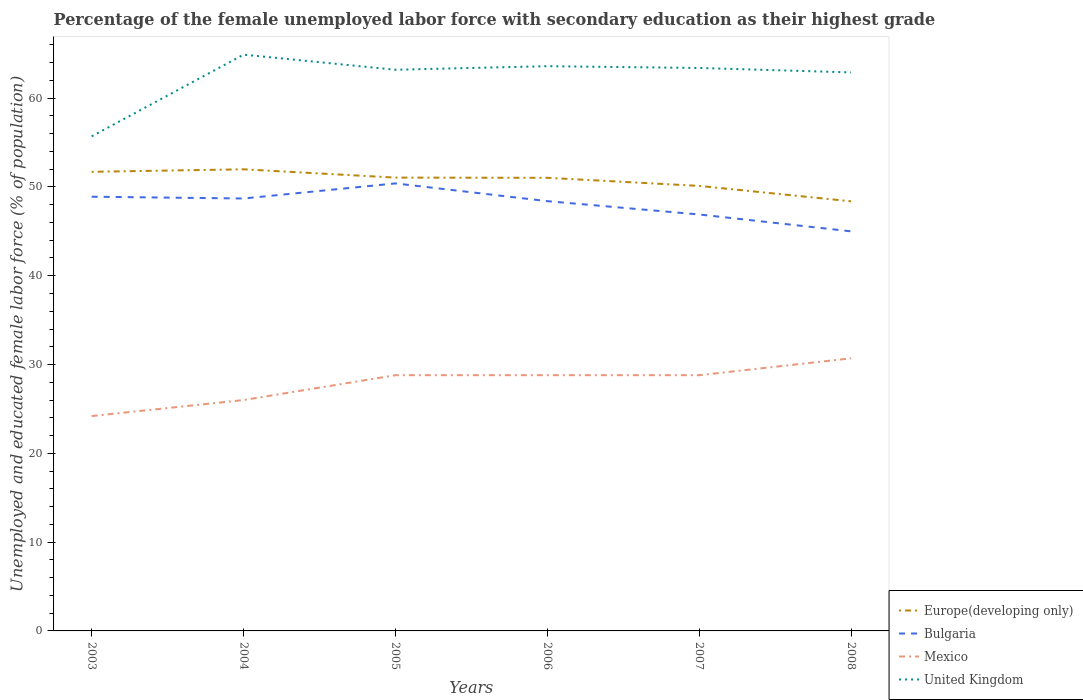How many different coloured lines are there?
Offer a terse response. 4. Is the number of lines equal to the number of legend labels?
Your response must be concise. Yes. What is the total percentage of the unemployed female labor force with secondary education in United Kingdom in the graph?
Your response must be concise. -7.9. Is the percentage of the unemployed female labor force with secondary education in United Kingdom strictly greater than the percentage of the unemployed female labor force with secondary education in Europe(developing only) over the years?
Provide a succinct answer. No. How many years are there in the graph?
Make the answer very short. 6. Are the values on the major ticks of Y-axis written in scientific E-notation?
Provide a succinct answer. No. Does the graph contain grids?
Give a very brief answer. No. Where does the legend appear in the graph?
Offer a terse response. Bottom right. How are the legend labels stacked?
Your answer should be compact. Vertical. What is the title of the graph?
Offer a very short reply. Percentage of the female unemployed labor force with secondary education as their highest grade. Does "Aruba" appear as one of the legend labels in the graph?
Offer a very short reply. No. What is the label or title of the X-axis?
Provide a short and direct response. Years. What is the label or title of the Y-axis?
Your response must be concise. Unemployed and educated female labor force (% of population). What is the Unemployed and educated female labor force (% of population) of Europe(developing only) in 2003?
Make the answer very short. 51.71. What is the Unemployed and educated female labor force (% of population) in Bulgaria in 2003?
Ensure brevity in your answer.  48.9. What is the Unemployed and educated female labor force (% of population) in Mexico in 2003?
Your response must be concise. 24.2. What is the Unemployed and educated female labor force (% of population) of United Kingdom in 2003?
Offer a terse response. 55.7. What is the Unemployed and educated female labor force (% of population) of Europe(developing only) in 2004?
Your answer should be very brief. 51.99. What is the Unemployed and educated female labor force (% of population) of Bulgaria in 2004?
Your response must be concise. 48.7. What is the Unemployed and educated female labor force (% of population) in Mexico in 2004?
Offer a very short reply. 26. What is the Unemployed and educated female labor force (% of population) in United Kingdom in 2004?
Your answer should be very brief. 64.9. What is the Unemployed and educated female labor force (% of population) in Europe(developing only) in 2005?
Provide a succinct answer. 51.05. What is the Unemployed and educated female labor force (% of population) in Bulgaria in 2005?
Give a very brief answer. 50.4. What is the Unemployed and educated female labor force (% of population) in Mexico in 2005?
Ensure brevity in your answer.  28.8. What is the Unemployed and educated female labor force (% of population) in United Kingdom in 2005?
Offer a very short reply. 63.2. What is the Unemployed and educated female labor force (% of population) of Europe(developing only) in 2006?
Offer a terse response. 51.03. What is the Unemployed and educated female labor force (% of population) in Bulgaria in 2006?
Offer a terse response. 48.4. What is the Unemployed and educated female labor force (% of population) in Mexico in 2006?
Offer a terse response. 28.8. What is the Unemployed and educated female labor force (% of population) of United Kingdom in 2006?
Ensure brevity in your answer.  63.6. What is the Unemployed and educated female labor force (% of population) in Europe(developing only) in 2007?
Your response must be concise. 50.12. What is the Unemployed and educated female labor force (% of population) of Bulgaria in 2007?
Your answer should be compact. 46.9. What is the Unemployed and educated female labor force (% of population) in Mexico in 2007?
Your answer should be very brief. 28.8. What is the Unemployed and educated female labor force (% of population) in United Kingdom in 2007?
Make the answer very short. 63.4. What is the Unemployed and educated female labor force (% of population) of Europe(developing only) in 2008?
Provide a short and direct response. 48.38. What is the Unemployed and educated female labor force (% of population) of Bulgaria in 2008?
Offer a very short reply. 45. What is the Unemployed and educated female labor force (% of population) of Mexico in 2008?
Provide a short and direct response. 30.7. What is the Unemployed and educated female labor force (% of population) in United Kingdom in 2008?
Make the answer very short. 62.9. Across all years, what is the maximum Unemployed and educated female labor force (% of population) in Europe(developing only)?
Provide a short and direct response. 51.99. Across all years, what is the maximum Unemployed and educated female labor force (% of population) in Bulgaria?
Offer a very short reply. 50.4. Across all years, what is the maximum Unemployed and educated female labor force (% of population) in Mexico?
Make the answer very short. 30.7. Across all years, what is the maximum Unemployed and educated female labor force (% of population) of United Kingdom?
Give a very brief answer. 64.9. Across all years, what is the minimum Unemployed and educated female labor force (% of population) of Europe(developing only)?
Ensure brevity in your answer.  48.38. Across all years, what is the minimum Unemployed and educated female labor force (% of population) in Bulgaria?
Offer a terse response. 45. Across all years, what is the minimum Unemployed and educated female labor force (% of population) of Mexico?
Your response must be concise. 24.2. Across all years, what is the minimum Unemployed and educated female labor force (% of population) of United Kingdom?
Provide a short and direct response. 55.7. What is the total Unemployed and educated female labor force (% of population) in Europe(developing only) in the graph?
Keep it short and to the point. 304.28. What is the total Unemployed and educated female labor force (% of population) in Bulgaria in the graph?
Make the answer very short. 288.3. What is the total Unemployed and educated female labor force (% of population) in Mexico in the graph?
Offer a terse response. 167.3. What is the total Unemployed and educated female labor force (% of population) in United Kingdom in the graph?
Provide a succinct answer. 373.7. What is the difference between the Unemployed and educated female labor force (% of population) in Europe(developing only) in 2003 and that in 2004?
Your answer should be very brief. -0.28. What is the difference between the Unemployed and educated female labor force (% of population) in Mexico in 2003 and that in 2004?
Ensure brevity in your answer.  -1.8. What is the difference between the Unemployed and educated female labor force (% of population) in United Kingdom in 2003 and that in 2004?
Offer a very short reply. -9.2. What is the difference between the Unemployed and educated female labor force (% of population) in Europe(developing only) in 2003 and that in 2005?
Give a very brief answer. 0.65. What is the difference between the Unemployed and educated female labor force (% of population) of Europe(developing only) in 2003 and that in 2006?
Your answer should be compact. 0.67. What is the difference between the Unemployed and educated female labor force (% of population) of Bulgaria in 2003 and that in 2006?
Provide a succinct answer. 0.5. What is the difference between the Unemployed and educated female labor force (% of population) in Europe(developing only) in 2003 and that in 2007?
Your answer should be very brief. 1.59. What is the difference between the Unemployed and educated female labor force (% of population) in Mexico in 2003 and that in 2007?
Offer a very short reply. -4.6. What is the difference between the Unemployed and educated female labor force (% of population) in Europe(developing only) in 2003 and that in 2008?
Give a very brief answer. 3.32. What is the difference between the Unemployed and educated female labor force (% of population) in United Kingdom in 2003 and that in 2008?
Keep it short and to the point. -7.2. What is the difference between the Unemployed and educated female labor force (% of population) in Europe(developing only) in 2004 and that in 2005?
Provide a succinct answer. 0.93. What is the difference between the Unemployed and educated female labor force (% of population) of Bulgaria in 2004 and that in 2005?
Give a very brief answer. -1.7. What is the difference between the Unemployed and educated female labor force (% of population) in Mexico in 2004 and that in 2005?
Offer a very short reply. -2.8. What is the difference between the Unemployed and educated female labor force (% of population) in Europe(developing only) in 2004 and that in 2006?
Provide a short and direct response. 0.96. What is the difference between the Unemployed and educated female labor force (% of population) in Europe(developing only) in 2004 and that in 2007?
Provide a short and direct response. 1.87. What is the difference between the Unemployed and educated female labor force (% of population) in Bulgaria in 2004 and that in 2007?
Your answer should be very brief. 1.8. What is the difference between the Unemployed and educated female labor force (% of population) of Mexico in 2004 and that in 2007?
Give a very brief answer. -2.8. What is the difference between the Unemployed and educated female labor force (% of population) in United Kingdom in 2004 and that in 2007?
Offer a terse response. 1.5. What is the difference between the Unemployed and educated female labor force (% of population) in Europe(developing only) in 2004 and that in 2008?
Your answer should be compact. 3.6. What is the difference between the Unemployed and educated female labor force (% of population) in Mexico in 2004 and that in 2008?
Your answer should be compact. -4.7. What is the difference between the Unemployed and educated female labor force (% of population) in United Kingdom in 2004 and that in 2008?
Your response must be concise. 2. What is the difference between the Unemployed and educated female labor force (% of population) in Europe(developing only) in 2005 and that in 2006?
Provide a succinct answer. 0.02. What is the difference between the Unemployed and educated female labor force (% of population) in Mexico in 2005 and that in 2006?
Your answer should be compact. 0. What is the difference between the Unemployed and educated female labor force (% of population) in United Kingdom in 2005 and that in 2006?
Your answer should be compact. -0.4. What is the difference between the Unemployed and educated female labor force (% of population) of Europe(developing only) in 2005 and that in 2007?
Offer a very short reply. 0.94. What is the difference between the Unemployed and educated female labor force (% of population) of Bulgaria in 2005 and that in 2007?
Make the answer very short. 3.5. What is the difference between the Unemployed and educated female labor force (% of population) in Europe(developing only) in 2005 and that in 2008?
Offer a terse response. 2.67. What is the difference between the Unemployed and educated female labor force (% of population) of Bulgaria in 2005 and that in 2008?
Make the answer very short. 5.4. What is the difference between the Unemployed and educated female labor force (% of population) of Mexico in 2005 and that in 2008?
Provide a short and direct response. -1.9. What is the difference between the Unemployed and educated female labor force (% of population) in Europe(developing only) in 2006 and that in 2007?
Keep it short and to the point. 0.91. What is the difference between the Unemployed and educated female labor force (% of population) in Mexico in 2006 and that in 2007?
Ensure brevity in your answer.  0. What is the difference between the Unemployed and educated female labor force (% of population) of United Kingdom in 2006 and that in 2007?
Your answer should be compact. 0.2. What is the difference between the Unemployed and educated female labor force (% of population) of Europe(developing only) in 2006 and that in 2008?
Your response must be concise. 2.65. What is the difference between the Unemployed and educated female labor force (% of population) of Bulgaria in 2006 and that in 2008?
Keep it short and to the point. 3.4. What is the difference between the Unemployed and educated female labor force (% of population) in Europe(developing only) in 2007 and that in 2008?
Your response must be concise. 1.73. What is the difference between the Unemployed and educated female labor force (% of population) of Mexico in 2007 and that in 2008?
Your answer should be compact. -1.9. What is the difference between the Unemployed and educated female labor force (% of population) in United Kingdom in 2007 and that in 2008?
Make the answer very short. 0.5. What is the difference between the Unemployed and educated female labor force (% of population) of Europe(developing only) in 2003 and the Unemployed and educated female labor force (% of population) of Bulgaria in 2004?
Ensure brevity in your answer.  3.01. What is the difference between the Unemployed and educated female labor force (% of population) of Europe(developing only) in 2003 and the Unemployed and educated female labor force (% of population) of Mexico in 2004?
Keep it short and to the point. 25.71. What is the difference between the Unemployed and educated female labor force (% of population) in Europe(developing only) in 2003 and the Unemployed and educated female labor force (% of population) in United Kingdom in 2004?
Your response must be concise. -13.19. What is the difference between the Unemployed and educated female labor force (% of population) in Bulgaria in 2003 and the Unemployed and educated female labor force (% of population) in Mexico in 2004?
Your answer should be compact. 22.9. What is the difference between the Unemployed and educated female labor force (% of population) in Bulgaria in 2003 and the Unemployed and educated female labor force (% of population) in United Kingdom in 2004?
Provide a succinct answer. -16. What is the difference between the Unemployed and educated female labor force (% of population) of Mexico in 2003 and the Unemployed and educated female labor force (% of population) of United Kingdom in 2004?
Give a very brief answer. -40.7. What is the difference between the Unemployed and educated female labor force (% of population) of Europe(developing only) in 2003 and the Unemployed and educated female labor force (% of population) of Bulgaria in 2005?
Ensure brevity in your answer.  1.31. What is the difference between the Unemployed and educated female labor force (% of population) of Europe(developing only) in 2003 and the Unemployed and educated female labor force (% of population) of Mexico in 2005?
Offer a terse response. 22.91. What is the difference between the Unemployed and educated female labor force (% of population) in Europe(developing only) in 2003 and the Unemployed and educated female labor force (% of population) in United Kingdom in 2005?
Your answer should be compact. -11.49. What is the difference between the Unemployed and educated female labor force (% of population) in Bulgaria in 2003 and the Unemployed and educated female labor force (% of population) in Mexico in 2005?
Ensure brevity in your answer.  20.1. What is the difference between the Unemployed and educated female labor force (% of population) of Bulgaria in 2003 and the Unemployed and educated female labor force (% of population) of United Kingdom in 2005?
Ensure brevity in your answer.  -14.3. What is the difference between the Unemployed and educated female labor force (% of population) of Mexico in 2003 and the Unemployed and educated female labor force (% of population) of United Kingdom in 2005?
Make the answer very short. -39. What is the difference between the Unemployed and educated female labor force (% of population) in Europe(developing only) in 2003 and the Unemployed and educated female labor force (% of population) in Bulgaria in 2006?
Make the answer very short. 3.31. What is the difference between the Unemployed and educated female labor force (% of population) in Europe(developing only) in 2003 and the Unemployed and educated female labor force (% of population) in Mexico in 2006?
Keep it short and to the point. 22.91. What is the difference between the Unemployed and educated female labor force (% of population) in Europe(developing only) in 2003 and the Unemployed and educated female labor force (% of population) in United Kingdom in 2006?
Your answer should be compact. -11.89. What is the difference between the Unemployed and educated female labor force (% of population) of Bulgaria in 2003 and the Unemployed and educated female labor force (% of population) of Mexico in 2006?
Offer a terse response. 20.1. What is the difference between the Unemployed and educated female labor force (% of population) in Bulgaria in 2003 and the Unemployed and educated female labor force (% of population) in United Kingdom in 2006?
Your answer should be very brief. -14.7. What is the difference between the Unemployed and educated female labor force (% of population) of Mexico in 2003 and the Unemployed and educated female labor force (% of population) of United Kingdom in 2006?
Your response must be concise. -39.4. What is the difference between the Unemployed and educated female labor force (% of population) in Europe(developing only) in 2003 and the Unemployed and educated female labor force (% of population) in Bulgaria in 2007?
Provide a succinct answer. 4.81. What is the difference between the Unemployed and educated female labor force (% of population) in Europe(developing only) in 2003 and the Unemployed and educated female labor force (% of population) in Mexico in 2007?
Provide a succinct answer. 22.91. What is the difference between the Unemployed and educated female labor force (% of population) of Europe(developing only) in 2003 and the Unemployed and educated female labor force (% of population) of United Kingdom in 2007?
Offer a very short reply. -11.69. What is the difference between the Unemployed and educated female labor force (% of population) in Bulgaria in 2003 and the Unemployed and educated female labor force (% of population) in Mexico in 2007?
Ensure brevity in your answer.  20.1. What is the difference between the Unemployed and educated female labor force (% of population) in Bulgaria in 2003 and the Unemployed and educated female labor force (% of population) in United Kingdom in 2007?
Provide a short and direct response. -14.5. What is the difference between the Unemployed and educated female labor force (% of population) of Mexico in 2003 and the Unemployed and educated female labor force (% of population) of United Kingdom in 2007?
Offer a very short reply. -39.2. What is the difference between the Unemployed and educated female labor force (% of population) of Europe(developing only) in 2003 and the Unemployed and educated female labor force (% of population) of Bulgaria in 2008?
Provide a short and direct response. 6.71. What is the difference between the Unemployed and educated female labor force (% of population) in Europe(developing only) in 2003 and the Unemployed and educated female labor force (% of population) in Mexico in 2008?
Make the answer very short. 21.01. What is the difference between the Unemployed and educated female labor force (% of population) in Europe(developing only) in 2003 and the Unemployed and educated female labor force (% of population) in United Kingdom in 2008?
Provide a short and direct response. -11.19. What is the difference between the Unemployed and educated female labor force (% of population) of Bulgaria in 2003 and the Unemployed and educated female labor force (% of population) of Mexico in 2008?
Offer a very short reply. 18.2. What is the difference between the Unemployed and educated female labor force (% of population) of Bulgaria in 2003 and the Unemployed and educated female labor force (% of population) of United Kingdom in 2008?
Make the answer very short. -14. What is the difference between the Unemployed and educated female labor force (% of population) of Mexico in 2003 and the Unemployed and educated female labor force (% of population) of United Kingdom in 2008?
Keep it short and to the point. -38.7. What is the difference between the Unemployed and educated female labor force (% of population) in Europe(developing only) in 2004 and the Unemployed and educated female labor force (% of population) in Bulgaria in 2005?
Give a very brief answer. 1.59. What is the difference between the Unemployed and educated female labor force (% of population) of Europe(developing only) in 2004 and the Unemployed and educated female labor force (% of population) of Mexico in 2005?
Offer a terse response. 23.19. What is the difference between the Unemployed and educated female labor force (% of population) of Europe(developing only) in 2004 and the Unemployed and educated female labor force (% of population) of United Kingdom in 2005?
Provide a short and direct response. -11.21. What is the difference between the Unemployed and educated female labor force (% of population) of Bulgaria in 2004 and the Unemployed and educated female labor force (% of population) of Mexico in 2005?
Make the answer very short. 19.9. What is the difference between the Unemployed and educated female labor force (% of population) in Mexico in 2004 and the Unemployed and educated female labor force (% of population) in United Kingdom in 2005?
Keep it short and to the point. -37.2. What is the difference between the Unemployed and educated female labor force (% of population) of Europe(developing only) in 2004 and the Unemployed and educated female labor force (% of population) of Bulgaria in 2006?
Your answer should be very brief. 3.59. What is the difference between the Unemployed and educated female labor force (% of population) in Europe(developing only) in 2004 and the Unemployed and educated female labor force (% of population) in Mexico in 2006?
Keep it short and to the point. 23.19. What is the difference between the Unemployed and educated female labor force (% of population) of Europe(developing only) in 2004 and the Unemployed and educated female labor force (% of population) of United Kingdom in 2006?
Provide a short and direct response. -11.61. What is the difference between the Unemployed and educated female labor force (% of population) in Bulgaria in 2004 and the Unemployed and educated female labor force (% of population) in Mexico in 2006?
Your response must be concise. 19.9. What is the difference between the Unemployed and educated female labor force (% of population) in Bulgaria in 2004 and the Unemployed and educated female labor force (% of population) in United Kingdom in 2006?
Provide a short and direct response. -14.9. What is the difference between the Unemployed and educated female labor force (% of population) of Mexico in 2004 and the Unemployed and educated female labor force (% of population) of United Kingdom in 2006?
Keep it short and to the point. -37.6. What is the difference between the Unemployed and educated female labor force (% of population) in Europe(developing only) in 2004 and the Unemployed and educated female labor force (% of population) in Bulgaria in 2007?
Provide a short and direct response. 5.09. What is the difference between the Unemployed and educated female labor force (% of population) of Europe(developing only) in 2004 and the Unemployed and educated female labor force (% of population) of Mexico in 2007?
Make the answer very short. 23.19. What is the difference between the Unemployed and educated female labor force (% of population) of Europe(developing only) in 2004 and the Unemployed and educated female labor force (% of population) of United Kingdom in 2007?
Provide a short and direct response. -11.41. What is the difference between the Unemployed and educated female labor force (% of population) in Bulgaria in 2004 and the Unemployed and educated female labor force (% of population) in Mexico in 2007?
Give a very brief answer. 19.9. What is the difference between the Unemployed and educated female labor force (% of population) of Bulgaria in 2004 and the Unemployed and educated female labor force (% of population) of United Kingdom in 2007?
Ensure brevity in your answer.  -14.7. What is the difference between the Unemployed and educated female labor force (% of population) of Mexico in 2004 and the Unemployed and educated female labor force (% of population) of United Kingdom in 2007?
Offer a terse response. -37.4. What is the difference between the Unemployed and educated female labor force (% of population) of Europe(developing only) in 2004 and the Unemployed and educated female labor force (% of population) of Bulgaria in 2008?
Offer a terse response. 6.99. What is the difference between the Unemployed and educated female labor force (% of population) of Europe(developing only) in 2004 and the Unemployed and educated female labor force (% of population) of Mexico in 2008?
Your answer should be compact. 21.29. What is the difference between the Unemployed and educated female labor force (% of population) of Europe(developing only) in 2004 and the Unemployed and educated female labor force (% of population) of United Kingdom in 2008?
Keep it short and to the point. -10.91. What is the difference between the Unemployed and educated female labor force (% of population) in Mexico in 2004 and the Unemployed and educated female labor force (% of population) in United Kingdom in 2008?
Your answer should be compact. -36.9. What is the difference between the Unemployed and educated female labor force (% of population) in Europe(developing only) in 2005 and the Unemployed and educated female labor force (% of population) in Bulgaria in 2006?
Keep it short and to the point. 2.65. What is the difference between the Unemployed and educated female labor force (% of population) in Europe(developing only) in 2005 and the Unemployed and educated female labor force (% of population) in Mexico in 2006?
Ensure brevity in your answer.  22.25. What is the difference between the Unemployed and educated female labor force (% of population) of Europe(developing only) in 2005 and the Unemployed and educated female labor force (% of population) of United Kingdom in 2006?
Your answer should be very brief. -12.55. What is the difference between the Unemployed and educated female labor force (% of population) in Bulgaria in 2005 and the Unemployed and educated female labor force (% of population) in Mexico in 2006?
Give a very brief answer. 21.6. What is the difference between the Unemployed and educated female labor force (% of population) in Mexico in 2005 and the Unemployed and educated female labor force (% of population) in United Kingdom in 2006?
Provide a succinct answer. -34.8. What is the difference between the Unemployed and educated female labor force (% of population) of Europe(developing only) in 2005 and the Unemployed and educated female labor force (% of population) of Bulgaria in 2007?
Keep it short and to the point. 4.15. What is the difference between the Unemployed and educated female labor force (% of population) in Europe(developing only) in 2005 and the Unemployed and educated female labor force (% of population) in Mexico in 2007?
Provide a short and direct response. 22.25. What is the difference between the Unemployed and educated female labor force (% of population) in Europe(developing only) in 2005 and the Unemployed and educated female labor force (% of population) in United Kingdom in 2007?
Ensure brevity in your answer.  -12.35. What is the difference between the Unemployed and educated female labor force (% of population) of Bulgaria in 2005 and the Unemployed and educated female labor force (% of population) of Mexico in 2007?
Provide a short and direct response. 21.6. What is the difference between the Unemployed and educated female labor force (% of population) in Mexico in 2005 and the Unemployed and educated female labor force (% of population) in United Kingdom in 2007?
Your answer should be compact. -34.6. What is the difference between the Unemployed and educated female labor force (% of population) in Europe(developing only) in 2005 and the Unemployed and educated female labor force (% of population) in Bulgaria in 2008?
Ensure brevity in your answer.  6.05. What is the difference between the Unemployed and educated female labor force (% of population) of Europe(developing only) in 2005 and the Unemployed and educated female labor force (% of population) of Mexico in 2008?
Your answer should be very brief. 20.35. What is the difference between the Unemployed and educated female labor force (% of population) in Europe(developing only) in 2005 and the Unemployed and educated female labor force (% of population) in United Kingdom in 2008?
Ensure brevity in your answer.  -11.85. What is the difference between the Unemployed and educated female labor force (% of population) of Bulgaria in 2005 and the Unemployed and educated female labor force (% of population) of Mexico in 2008?
Your response must be concise. 19.7. What is the difference between the Unemployed and educated female labor force (% of population) of Bulgaria in 2005 and the Unemployed and educated female labor force (% of population) of United Kingdom in 2008?
Your answer should be compact. -12.5. What is the difference between the Unemployed and educated female labor force (% of population) of Mexico in 2005 and the Unemployed and educated female labor force (% of population) of United Kingdom in 2008?
Keep it short and to the point. -34.1. What is the difference between the Unemployed and educated female labor force (% of population) of Europe(developing only) in 2006 and the Unemployed and educated female labor force (% of population) of Bulgaria in 2007?
Your answer should be compact. 4.13. What is the difference between the Unemployed and educated female labor force (% of population) in Europe(developing only) in 2006 and the Unemployed and educated female labor force (% of population) in Mexico in 2007?
Your answer should be very brief. 22.23. What is the difference between the Unemployed and educated female labor force (% of population) in Europe(developing only) in 2006 and the Unemployed and educated female labor force (% of population) in United Kingdom in 2007?
Your answer should be compact. -12.37. What is the difference between the Unemployed and educated female labor force (% of population) in Bulgaria in 2006 and the Unemployed and educated female labor force (% of population) in Mexico in 2007?
Offer a very short reply. 19.6. What is the difference between the Unemployed and educated female labor force (% of population) in Mexico in 2006 and the Unemployed and educated female labor force (% of population) in United Kingdom in 2007?
Provide a short and direct response. -34.6. What is the difference between the Unemployed and educated female labor force (% of population) of Europe(developing only) in 2006 and the Unemployed and educated female labor force (% of population) of Bulgaria in 2008?
Your answer should be compact. 6.03. What is the difference between the Unemployed and educated female labor force (% of population) in Europe(developing only) in 2006 and the Unemployed and educated female labor force (% of population) in Mexico in 2008?
Offer a terse response. 20.33. What is the difference between the Unemployed and educated female labor force (% of population) in Europe(developing only) in 2006 and the Unemployed and educated female labor force (% of population) in United Kingdom in 2008?
Provide a succinct answer. -11.87. What is the difference between the Unemployed and educated female labor force (% of population) in Bulgaria in 2006 and the Unemployed and educated female labor force (% of population) in Mexico in 2008?
Make the answer very short. 17.7. What is the difference between the Unemployed and educated female labor force (% of population) in Mexico in 2006 and the Unemployed and educated female labor force (% of population) in United Kingdom in 2008?
Offer a very short reply. -34.1. What is the difference between the Unemployed and educated female labor force (% of population) of Europe(developing only) in 2007 and the Unemployed and educated female labor force (% of population) of Bulgaria in 2008?
Give a very brief answer. 5.12. What is the difference between the Unemployed and educated female labor force (% of population) of Europe(developing only) in 2007 and the Unemployed and educated female labor force (% of population) of Mexico in 2008?
Make the answer very short. 19.42. What is the difference between the Unemployed and educated female labor force (% of population) in Europe(developing only) in 2007 and the Unemployed and educated female labor force (% of population) in United Kingdom in 2008?
Provide a short and direct response. -12.78. What is the difference between the Unemployed and educated female labor force (% of population) of Mexico in 2007 and the Unemployed and educated female labor force (% of population) of United Kingdom in 2008?
Offer a terse response. -34.1. What is the average Unemployed and educated female labor force (% of population) in Europe(developing only) per year?
Provide a succinct answer. 50.71. What is the average Unemployed and educated female labor force (% of population) of Bulgaria per year?
Offer a very short reply. 48.05. What is the average Unemployed and educated female labor force (% of population) of Mexico per year?
Ensure brevity in your answer.  27.88. What is the average Unemployed and educated female labor force (% of population) of United Kingdom per year?
Provide a succinct answer. 62.28. In the year 2003, what is the difference between the Unemployed and educated female labor force (% of population) of Europe(developing only) and Unemployed and educated female labor force (% of population) of Bulgaria?
Your answer should be compact. 2.81. In the year 2003, what is the difference between the Unemployed and educated female labor force (% of population) in Europe(developing only) and Unemployed and educated female labor force (% of population) in Mexico?
Give a very brief answer. 27.51. In the year 2003, what is the difference between the Unemployed and educated female labor force (% of population) in Europe(developing only) and Unemployed and educated female labor force (% of population) in United Kingdom?
Make the answer very short. -3.99. In the year 2003, what is the difference between the Unemployed and educated female labor force (% of population) in Bulgaria and Unemployed and educated female labor force (% of population) in Mexico?
Ensure brevity in your answer.  24.7. In the year 2003, what is the difference between the Unemployed and educated female labor force (% of population) of Mexico and Unemployed and educated female labor force (% of population) of United Kingdom?
Make the answer very short. -31.5. In the year 2004, what is the difference between the Unemployed and educated female labor force (% of population) in Europe(developing only) and Unemployed and educated female labor force (% of population) in Bulgaria?
Offer a terse response. 3.29. In the year 2004, what is the difference between the Unemployed and educated female labor force (% of population) in Europe(developing only) and Unemployed and educated female labor force (% of population) in Mexico?
Offer a terse response. 25.99. In the year 2004, what is the difference between the Unemployed and educated female labor force (% of population) of Europe(developing only) and Unemployed and educated female labor force (% of population) of United Kingdom?
Offer a very short reply. -12.91. In the year 2004, what is the difference between the Unemployed and educated female labor force (% of population) of Bulgaria and Unemployed and educated female labor force (% of population) of Mexico?
Offer a terse response. 22.7. In the year 2004, what is the difference between the Unemployed and educated female labor force (% of population) of Bulgaria and Unemployed and educated female labor force (% of population) of United Kingdom?
Your answer should be compact. -16.2. In the year 2004, what is the difference between the Unemployed and educated female labor force (% of population) of Mexico and Unemployed and educated female labor force (% of population) of United Kingdom?
Your response must be concise. -38.9. In the year 2005, what is the difference between the Unemployed and educated female labor force (% of population) in Europe(developing only) and Unemployed and educated female labor force (% of population) in Bulgaria?
Provide a succinct answer. 0.65. In the year 2005, what is the difference between the Unemployed and educated female labor force (% of population) in Europe(developing only) and Unemployed and educated female labor force (% of population) in Mexico?
Ensure brevity in your answer.  22.25. In the year 2005, what is the difference between the Unemployed and educated female labor force (% of population) of Europe(developing only) and Unemployed and educated female labor force (% of population) of United Kingdom?
Make the answer very short. -12.15. In the year 2005, what is the difference between the Unemployed and educated female labor force (% of population) in Bulgaria and Unemployed and educated female labor force (% of population) in Mexico?
Your answer should be very brief. 21.6. In the year 2005, what is the difference between the Unemployed and educated female labor force (% of population) of Mexico and Unemployed and educated female labor force (% of population) of United Kingdom?
Your answer should be very brief. -34.4. In the year 2006, what is the difference between the Unemployed and educated female labor force (% of population) of Europe(developing only) and Unemployed and educated female labor force (% of population) of Bulgaria?
Provide a short and direct response. 2.63. In the year 2006, what is the difference between the Unemployed and educated female labor force (% of population) of Europe(developing only) and Unemployed and educated female labor force (% of population) of Mexico?
Offer a terse response. 22.23. In the year 2006, what is the difference between the Unemployed and educated female labor force (% of population) of Europe(developing only) and Unemployed and educated female labor force (% of population) of United Kingdom?
Make the answer very short. -12.57. In the year 2006, what is the difference between the Unemployed and educated female labor force (% of population) in Bulgaria and Unemployed and educated female labor force (% of population) in Mexico?
Provide a succinct answer. 19.6. In the year 2006, what is the difference between the Unemployed and educated female labor force (% of population) of Bulgaria and Unemployed and educated female labor force (% of population) of United Kingdom?
Ensure brevity in your answer.  -15.2. In the year 2006, what is the difference between the Unemployed and educated female labor force (% of population) in Mexico and Unemployed and educated female labor force (% of population) in United Kingdom?
Provide a succinct answer. -34.8. In the year 2007, what is the difference between the Unemployed and educated female labor force (% of population) of Europe(developing only) and Unemployed and educated female labor force (% of population) of Bulgaria?
Make the answer very short. 3.22. In the year 2007, what is the difference between the Unemployed and educated female labor force (% of population) of Europe(developing only) and Unemployed and educated female labor force (% of population) of Mexico?
Offer a terse response. 21.32. In the year 2007, what is the difference between the Unemployed and educated female labor force (% of population) in Europe(developing only) and Unemployed and educated female labor force (% of population) in United Kingdom?
Offer a very short reply. -13.28. In the year 2007, what is the difference between the Unemployed and educated female labor force (% of population) of Bulgaria and Unemployed and educated female labor force (% of population) of Mexico?
Offer a terse response. 18.1. In the year 2007, what is the difference between the Unemployed and educated female labor force (% of population) in Bulgaria and Unemployed and educated female labor force (% of population) in United Kingdom?
Offer a terse response. -16.5. In the year 2007, what is the difference between the Unemployed and educated female labor force (% of population) of Mexico and Unemployed and educated female labor force (% of population) of United Kingdom?
Your answer should be very brief. -34.6. In the year 2008, what is the difference between the Unemployed and educated female labor force (% of population) of Europe(developing only) and Unemployed and educated female labor force (% of population) of Bulgaria?
Keep it short and to the point. 3.38. In the year 2008, what is the difference between the Unemployed and educated female labor force (% of population) in Europe(developing only) and Unemployed and educated female labor force (% of population) in Mexico?
Offer a terse response. 17.68. In the year 2008, what is the difference between the Unemployed and educated female labor force (% of population) in Europe(developing only) and Unemployed and educated female labor force (% of population) in United Kingdom?
Your answer should be very brief. -14.52. In the year 2008, what is the difference between the Unemployed and educated female labor force (% of population) of Bulgaria and Unemployed and educated female labor force (% of population) of United Kingdom?
Make the answer very short. -17.9. In the year 2008, what is the difference between the Unemployed and educated female labor force (% of population) of Mexico and Unemployed and educated female labor force (% of population) of United Kingdom?
Provide a short and direct response. -32.2. What is the ratio of the Unemployed and educated female labor force (% of population) in Europe(developing only) in 2003 to that in 2004?
Your answer should be very brief. 0.99. What is the ratio of the Unemployed and educated female labor force (% of population) of Bulgaria in 2003 to that in 2004?
Your response must be concise. 1. What is the ratio of the Unemployed and educated female labor force (% of population) of Mexico in 2003 to that in 2004?
Your response must be concise. 0.93. What is the ratio of the Unemployed and educated female labor force (% of population) of United Kingdom in 2003 to that in 2004?
Keep it short and to the point. 0.86. What is the ratio of the Unemployed and educated female labor force (% of population) in Europe(developing only) in 2003 to that in 2005?
Provide a short and direct response. 1.01. What is the ratio of the Unemployed and educated female labor force (% of population) in Bulgaria in 2003 to that in 2005?
Your response must be concise. 0.97. What is the ratio of the Unemployed and educated female labor force (% of population) in Mexico in 2003 to that in 2005?
Ensure brevity in your answer.  0.84. What is the ratio of the Unemployed and educated female labor force (% of population) of United Kingdom in 2003 to that in 2005?
Give a very brief answer. 0.88. What is the ratio of the Unemployed and educated female labor force (% of population) in Europe(developing only) in 2003 to that in 2006?
Offer a terse response. 1.01. What is the ratio of the Unemployed and educated female labor force (% of population) in Bulgaria in 2003 to that in 2006?
Provide a short and direct response. 1.01. What is the ratio of the Unemployed and educated female labor force (% of population) of Mexico in 2003 to that in 2006?
Provide a short and direct response. 0.84. What is the ratio of the Unemployed and educated female labor force (% of population) in United Kingdom in 2003 to that in 2006?
Your response must be concise. 0.88. What is the ratio of the Unemployed and educated female labor force (% of population) of Europe(developing only) in 2003 to that in 2007?
Give a very brief answer. 1.03. What is the ratio of the Unemployed and educated female labor force (% of population) in Bulgaria in 2003 to that in 2007?
Your answer should be very brief. 1.04. What is the ratio of the Unemployed and educated female labor force (% of population) of Mexico in 2003 to that in 2007?
Give a very brief answer. 0.84. What is the ratio of the Unemployed and educated female labor force (% of population) in United Kingdom in 2003 to that in 2007?
Your response must be concise. 0.88. What is the ratio of the Unemployed and educated female labor force (% of population) in Europe(developing only) in 2003 to that in 2008?
Offer a very short reply. 1.07. What is the ratio of the Unemployed and educated female labor force (% of population) of Bulgaria in 2003 to that in 2008?
Provide a succinct answer. 1.09. What is the ratio of the Unemployed and educated female labor force (% of population) of Mexico in 2003 to that in 2008?
Ensure brevity in your answer.  0.79. What is the ratio of the Unemployed and educated female labor force (% of population) in United Kingdom in 2003 to that in 2008?
Provide a succinct answer. 0.89. What is the ratio of the Unemployed and educated female labor force (% of population) in Europe(developing only) in 2004 to that in 2005?
Provide a short and direct response. 1.02. What is the ratio of the Unemployed and educated female labor force (% of population) of Bulgaria in 2004 to that in 2005?
Offer a very short reply. 0.97. What is the ratio of the Unemployed and educated female labor force (% of population) in Mexico in 2004 to that in 2005?
Provide a succinct answer. 0.9. What is the ratio of the Unemployed and educated female labor force (% of population) of United Kingdom in 2004 to that in 2005?
Make the answer very short. 1.03. What is the ratio of the Unemployed and educated female labor force (% of population) in Europe(developing only) in 2004 to that in 2006?
Offer a very short reply. 1.02. What is the ratio of the Unemployed and educated female labor force (% of population) of Bulgaria in 2004 to that in 2006?
Give a very brief answer. 1.01. What is the ratio of the Unemployed and educated female labor force (% of population) in Mexico in 2004 to that in 2006?
Provide a succinct answer. 0.9. What is the ratio of the Unemployed and educated female labor force (% of population) in United Kingdom in 2004 to that in 2006?
Provide a short and direct response. 1.02. What is the ratio of the Unemployed and educated female labor force (% of population) of Europe(developing only) in 2004 to that in 2007?
Ensure brevity in your answer.  1.04. What is the ratio of the Unemployed and educated female labor force (% of population) in Bulgaria in 2004 to that in 2007?
Offer a very short reply. 1.04. What is the ratio of the Unemployed and educated female labor force (% of population) of Mexico in 2004 to that in 2007?
Provide a short and direct response. 0.9. What is the ratio of the Unemployed and educated female labor force (% of population) of United Kingdom in 2004 to that in 2007?
Ensure brevity in your answer.  1.02. What is the ratio of the Unemployed and educated female labor force (% of population) in Europe(developing only) in 2004 to that in 2008?
Your answer should be very brief. 1.07. What is the ratio of the Unemployed and educated female labor force (% of population) of Bulgaria in 2004 to that in 2008?
Keep it short and to the point. 1.08. What is the ratio of the Unemployed and educated female labor force (% of population) in Mexico in 2004 to that in 2008?
Your response must be concise. 0.85. What is the ratio of the Unemployed and educated female labor force (% of population) of United Kingdom in 2004 to that in 2008?
Your answer should be compact. 1.03. What is the ratio of the Unemployed and educated female labor force (% of population) of Europe(developing only) in 2005 to that in 2006?
Your response must be concise. 1. What is the ratio of the Unemployed and educated female labor force (% of population) of Bulgaria in 2005 to that in 2006?
Give a very brief answer. 1.04. What is the ratio of the Unemployed and educated female labor force (% of population) of Mexico in 2005 to that in 2006?
Your answer should be very brief. 1. What is the ratio of the Unemployed and educated female labor force (% of population) in Europe(developing only) in 2005 to that in 2007?
Your answer should be very brief. 1.02. What is the ratio of the Unemployed and educated female labor force (% of population) of Bulgaria in 2005 to that in 2007?
Your response must be concise. 1.07. What is the ratio of the Unemployed and educated female labor force (% of population) in Europe(developing only) in 2005 to that in 2008?
Offer a very short reply. 1.06. What is the ratio of the Unemployed and educated female labor force (% of population) of Bulgaria in 2005 to that in 2008?
Offer a terse response. 1.12. What is the ratio of the Unemployed and educated female labor force (% of population) of Mexico in 2005 to that in 2008?
Your answer should be compact. 0.94. What is the ratio of the Unemployed and educated female labor force (% of population) of United Kingdom in 2005 to that in 2008?
Your answer should be very brief. 1. What is the ratio of the Unemployed and educated female labor force (% of population) of Europe(developing only) in 2006 to that in 2007?
Your answer should be compact. 1.02. What is the ratio of the Unemployed and educated female labor force (% of population) in Bulgaria in 2006 to that in 2007?
Give a very brief answer. 1.03. What is the ratio of the Unemployed and educated female labor force (% of population) in Mexico in 2006 to that in 2007?
Offer a very short reply. 1. What is the ratio of the Unemployed and educated female labor force (% of population) of Europe(developing only) in 2006 to that in 2008?
Make the answer very short. 1.05. What is the ratio of the Unemployed and educated female labor force (% of population) in Bulgaria in 2006 to that in 2008?
Provide a succinct answer. 1.08. What is the ratio of the Unemployed and educated female labor force (% of population) of Mexico in 2006 to that in 2008?
Your answer should be very brief. 0.94. What is the ratio of the Unemployed and educated female labor force (% of population) in United Kingdom in 2006 to that in 2008?
Keep it short and to the point. 1.01. What is the ratio of the Unemployed and educated female labor force (% of population) in Europe(developing only) in 2007 to that in 2008?
Your response must be concise. 1.04. What is the ratio of the Unemployed and educated female labor force (% of population) in Bulgaria in 2007 to that in 2008?
Make the answer very short. 1.04. What is the ratio of the Unemployed and educated female labor force (% of population) in Mexico in 2007 to that in 2008?
Keep it short and to the point. 0.94. What is the ratio of the Unemployed and educated female labor force (% of population) in United Kingdom in 2007 to that in 2008?
Give a very brief answer. 1.01. What is the difference between the highest and the second highest Unemployed and educated female labor force (% of population) of Europe(developing only)?
Provide a succinct answer. 0.28. What is the difference between the highest and the second highest Unemployed and educated female labor force (% of population) in United Kingdom?
Your answer should be compact. 1.3. What is the difference between the highest and the lowest Unemployed and educated female labor force (% of population) in Europe(developing only)?
Offer a very short reply. 3.6. What is the difference between the highest and the lowest Unemployed and educated female labor force (% of population) in Mexico?
Provide a short and direct response. 6.5. 